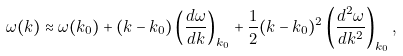Convert formula to latex. <formula><loc_0><loc_0><loc_500><loc_500>\omega ( k ) \approx \omega ( k _ { 0 } ) + ( k - k _ { 0 } ) \left ( { \frac { d \omega } { d k } } \right ) _ { k _ { 0 } } + \frac { 1 } { 2 } ( k - k _ { 0 } ) ^ { 2 } \left ( { \frac { d ^ { 2 } \omega } { d k ^ { 2 } } } \right ) _ { k _ { 0 } } ,</formula> 